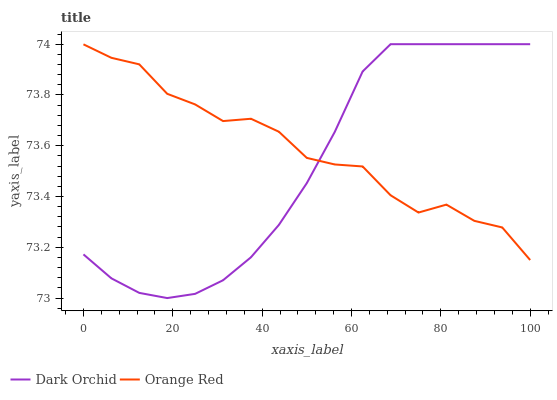Does Dark Orchid have the minimum area under the curve?
Answer yes or no. Yes. Does Orange Red have the maximum area under the curve?
Answer yes or no. Yes. Does Dark Orchid have the maximum area under the curve?
Answer yes or no. No. Is Dark Orchid the smoothest?
Answer yes or no. Yes. Is Orange Red the roughest?
Answer yes or no. Yes. Is Dark Orchid the roughest?
Answer yes or no. No. Does Dark Orchid have the lowest value?
Answer yes or no. Yes. Does Dark Orchid have the highest value?
Answer yes or no. Yes. Does Orange Red intersect Dark Orchid?
Answer yes or no. Yes. Is Orange Red less than Dark Orchid?
Answer yes or no. No. Is Orange Red greater than Dark Orchid?
Answer yes or no. No. 